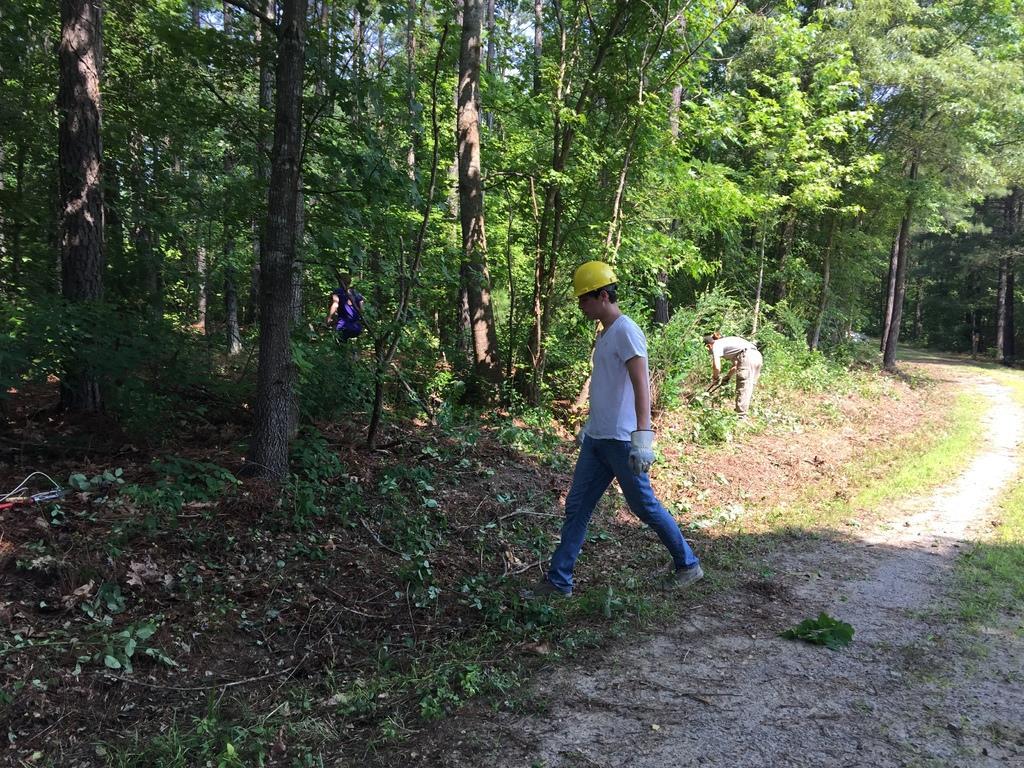How would you summarize this image in a sentence or two? In this image we can see a person wearing white T-shirt, helmet, gloves and shoes is walking on the road. Here we can see two more people, here we can see the way, plants, dry leaves on the ground and trees in the background. 